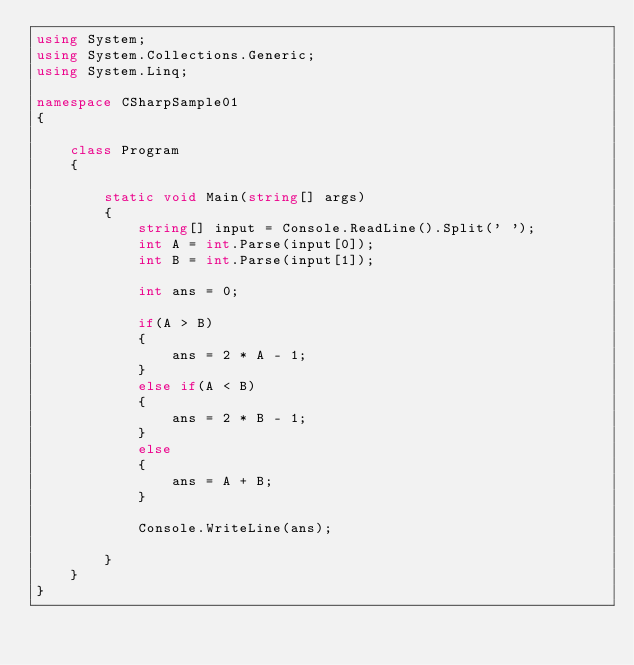Convert code to text. <code><loc_0><loc_0><loc_500><loc_500><_C#_>using System;
using System.Collections.Generic;
using System.Linq;

namespace CSharpSample01
{
    
    class Program
    {
        
        static void Main(string[] args)
        {
            string[] input = Console.ReadLine().Split(' ');
            int A = int.Parse(input[0]);
            int B = int.Parse(input[1]);
            
            int ans = 0;

            if(A > B)
            {
                ans = 2 * A - 1;
            }
            else if(A < B)
            {
                ans = 2 * B - 1;
            }
            else
            {
                ans = A + B;
            }
            
            Console.WriteLine(ans);
            
        }
    }
}
</code> 